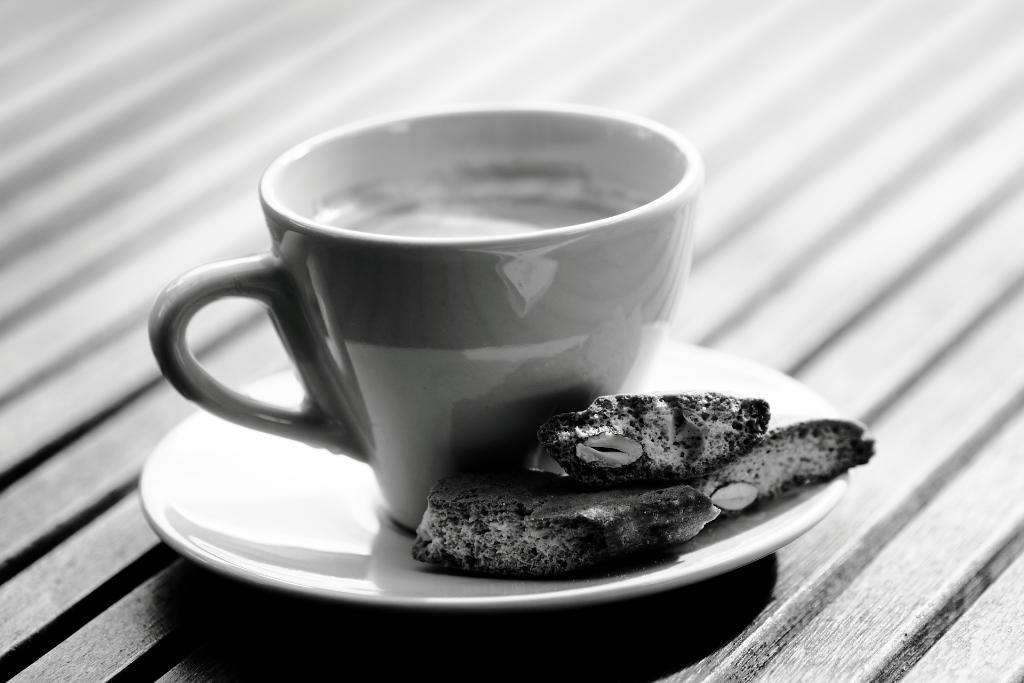What is in the cup that is visible in the image? There is a cup of coffee in the image. Besides coffee, what other items can be seen in the image? There are biscuits and a saucer visible in the image. Where are these items placed in the image? All of these items are placed on a table. What type of silk fabric is draped over the visitor's chair in the image? There is no silk fabric or visitor's chair present in the image; it only features a cup of coffee, biscuits, and a saucer on a table. 